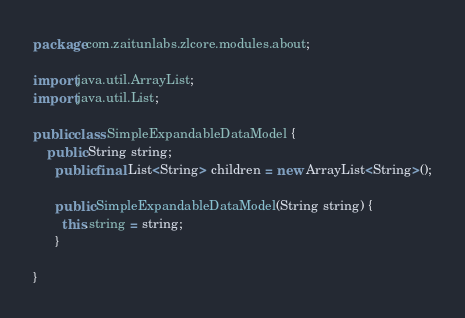<code> <loc_0><loc_0><loc_500><loc_500><_Java_>package com.zaitunlabs.zlcore.modules.about;

import java.util.ArrayList;
import java.util.List;

public class SimpleExpandableDataModel {
	public String string;
	  public final List<String> children = new ArrayList<String>();

	  public SimpleExpandableDataModel(String string) {
	    this.string = string;
	  }

}
</code> 